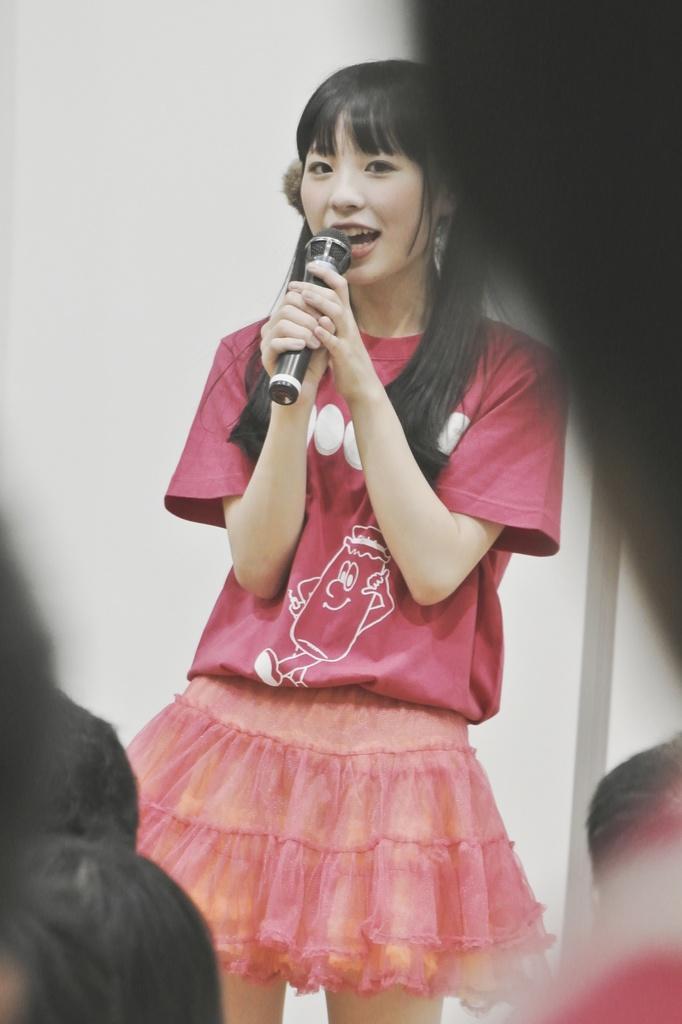In one or two sentences, can you explain what this image depicts? In this Picture we can see a pretty woman wearing pink t-shirt and small skirt is standing on the stage and singing in the microphone. 